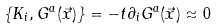<formula> <loc_0><loc_0><loc_500><loc_500>\{ K _ { i } , G ^ { a } ( \vec { x } ) \} = - t \partial _ { i } G ^ { a } ( \vec { x } ) \approx 0</formula> 